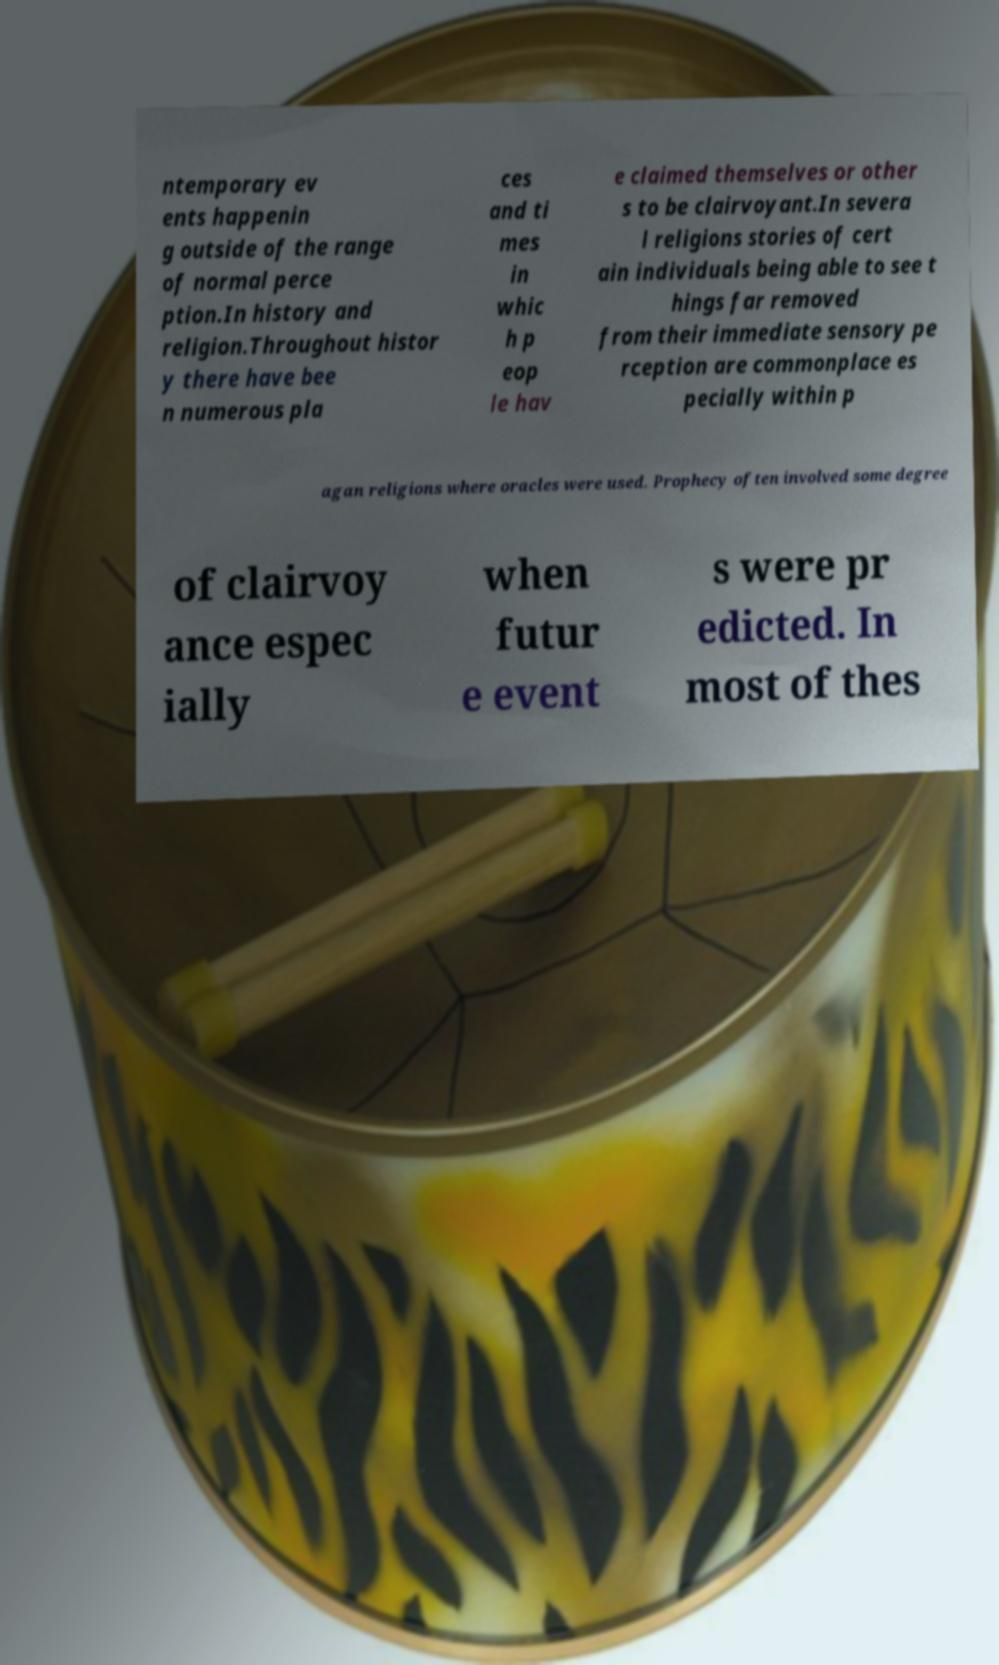What messages or text are displayed in this image? I need them in a readable, typed format. ntemporary ev ents happenin g outside of the range of normal perce ption.In history and religion.Throughout histor y there have bee n numerous pla ces and ti mes in whic h p eop le hav e claimed themselves or other s to be clairvoyant.In severa l religions stories of cert ain individuals being able to see t hings far removed from their immediate sensory pe rception are commonplace es pecially within p agan religions where oracles were used. Prophecy often involved some degree of clairvoy ance espec ially when futur e event s were pr edicted. In most of thes 